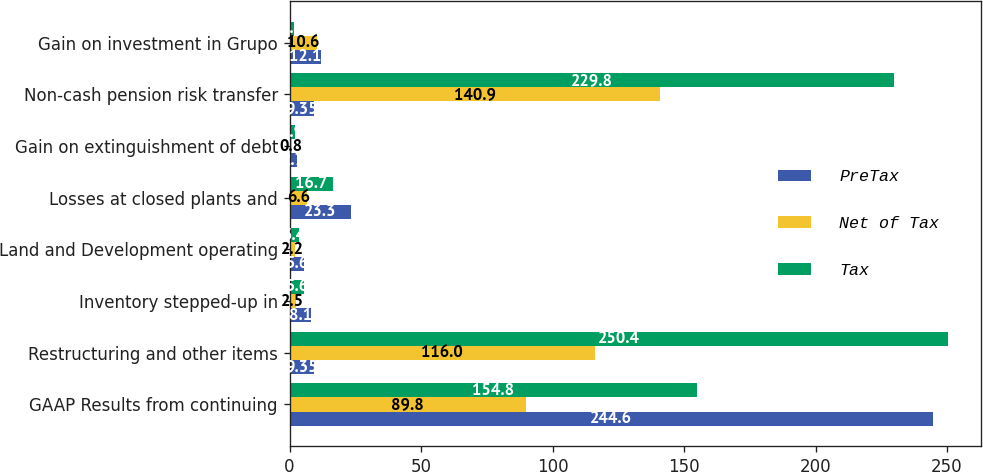Convert chart. <chart><loc_0><loc_0><loc_500><loc_500><stacked_bar_chart><ecel><fcel>GAAP Results from continuing<fcel>Restructuring and other items<fcel>Inventory stepped-up in<fcel>Land and Development operating<fcel>Losses at closed plants and<fcel>Gain on extinguishment of debt<fcel>Non-cash pension risk transfer<fcel>Gain on investment in Grupo<nl><fcel>PreTax<fcel>244.6<fcel>9.35<fcel>8.1<fcel>5.6<fcel>23.3<fcel>2.7<fcel>9.35<fcel>12.1<nl><fcel>Net of Tax<fcel>89.8<fcel>116<fcel>2.5<fcel>2.2<fcel>6.6<fcel>0.8<fcel>140.9<fcel>10.6<nl><fcel>Tax<fcel>154.8<fcel>250.4<fcel>5.6<fcel>3.4<fcel>16.7<fcel>1.9<fcel>229.8<fcel>1.5<nl></chart> 